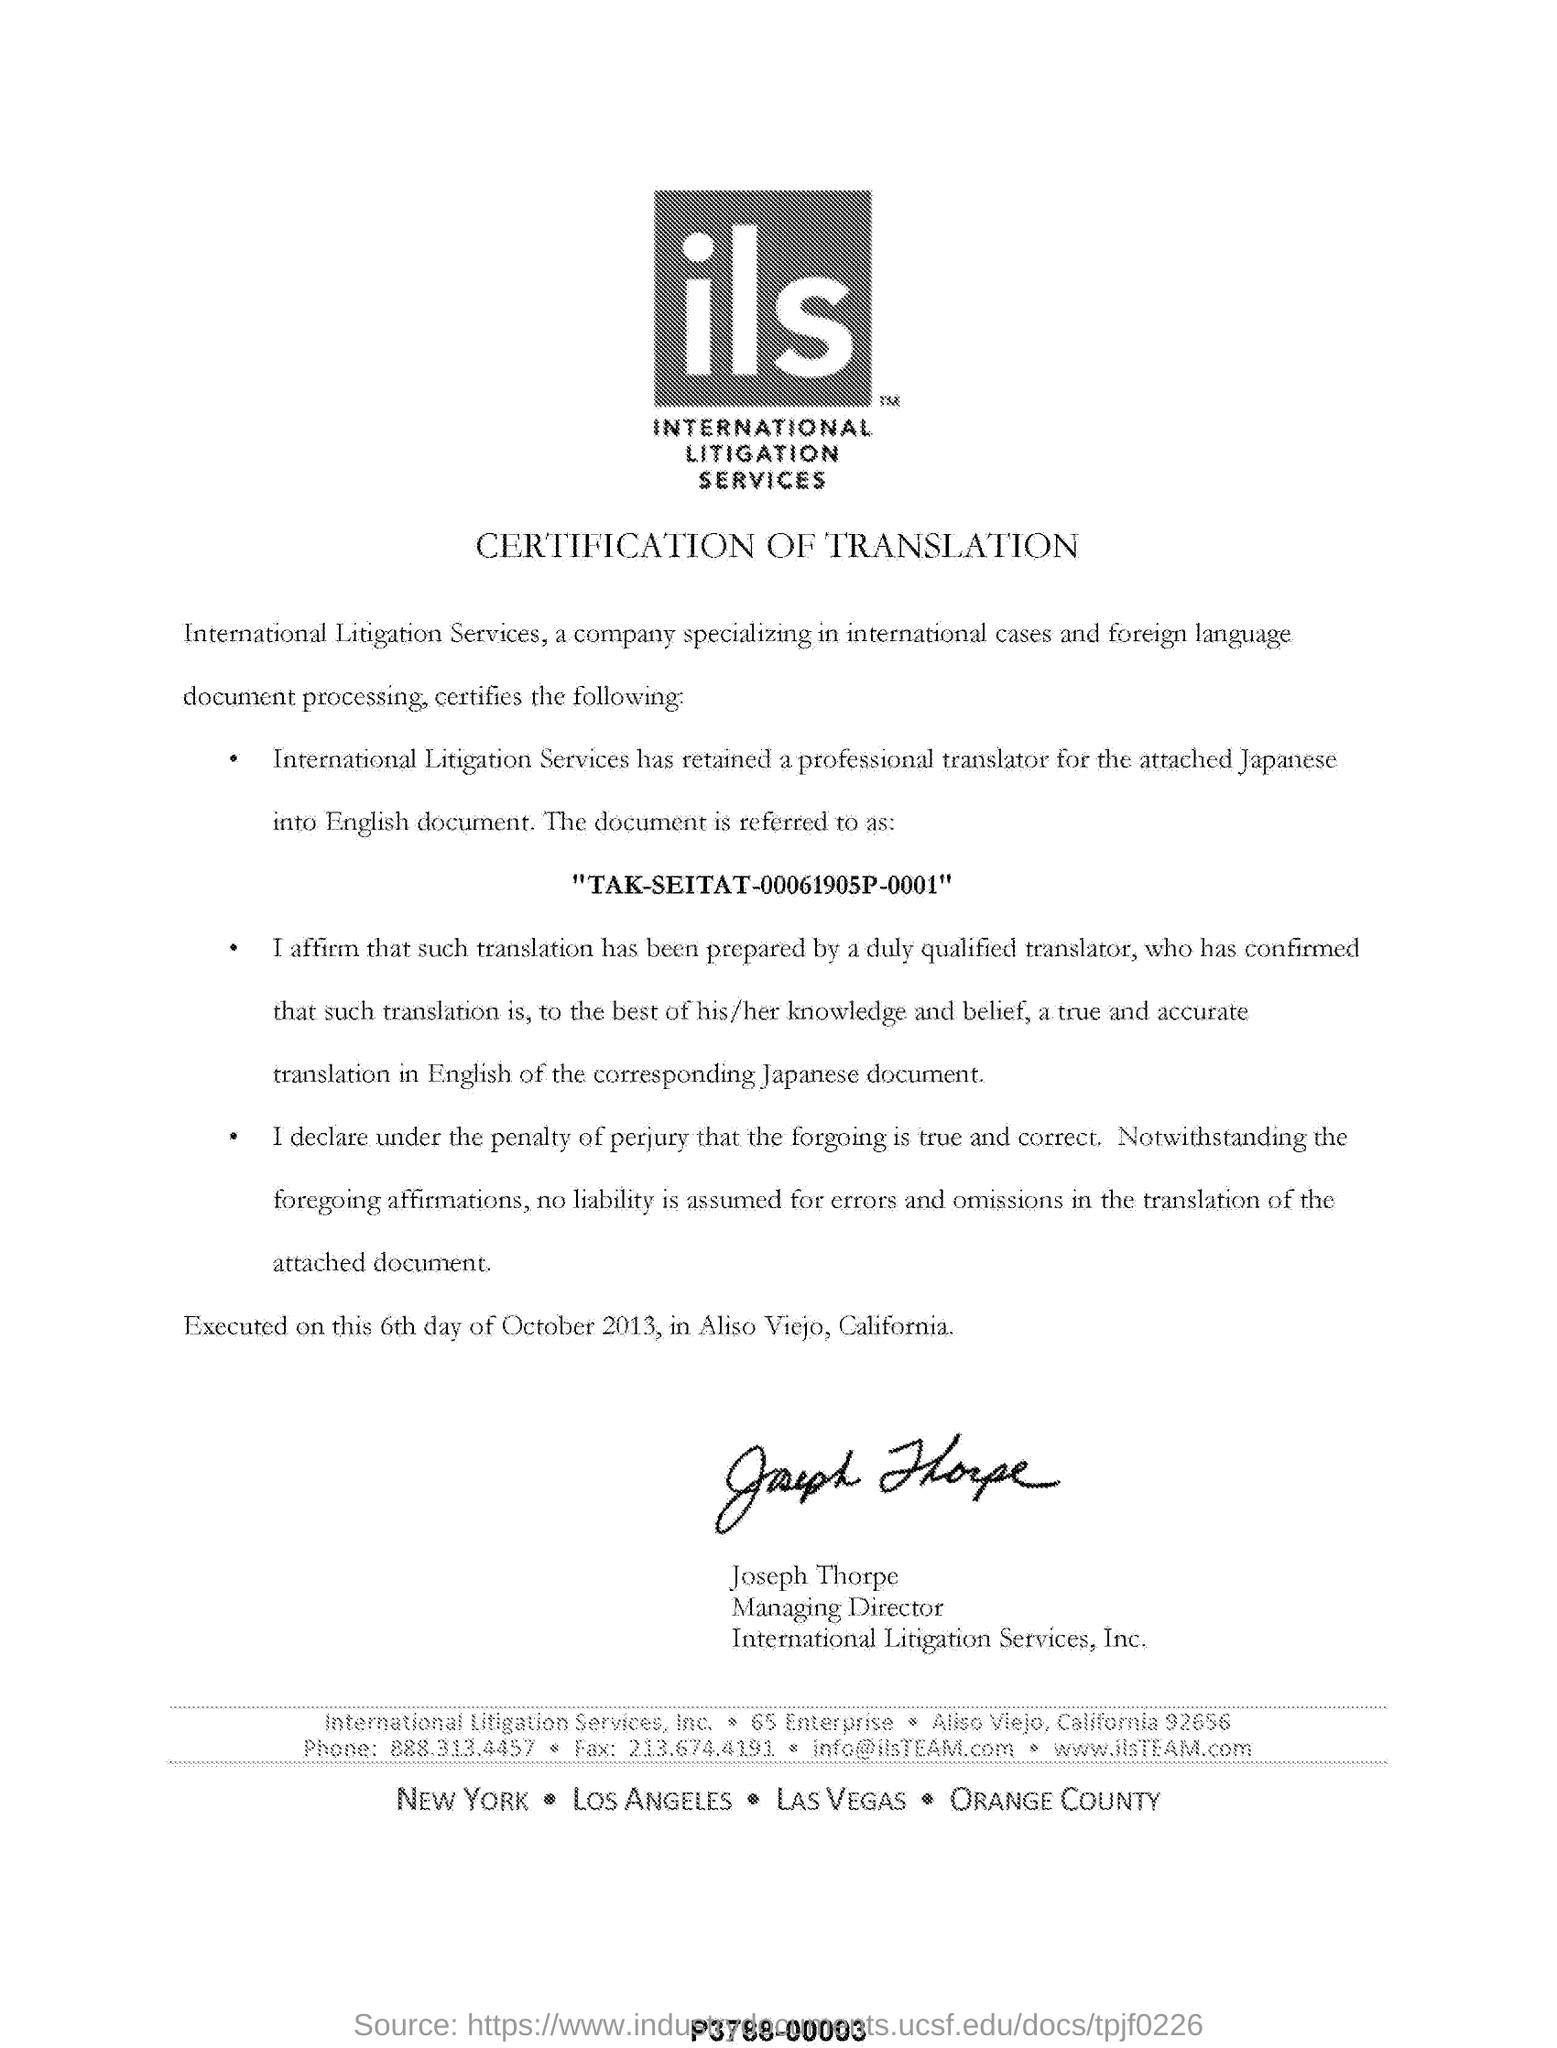What is the fullform of ils?
Your answer should be very brief. INTERNATIONAL LITIGATION SERVICES. What type of certification is mentioned in this document?
Provide a short and direct response. CERTIFICATION OF TRANSLATION. Who is the Managing Director of International Litigation Services, Inc?
Keep it short and to the point. Joseph thorpe. 